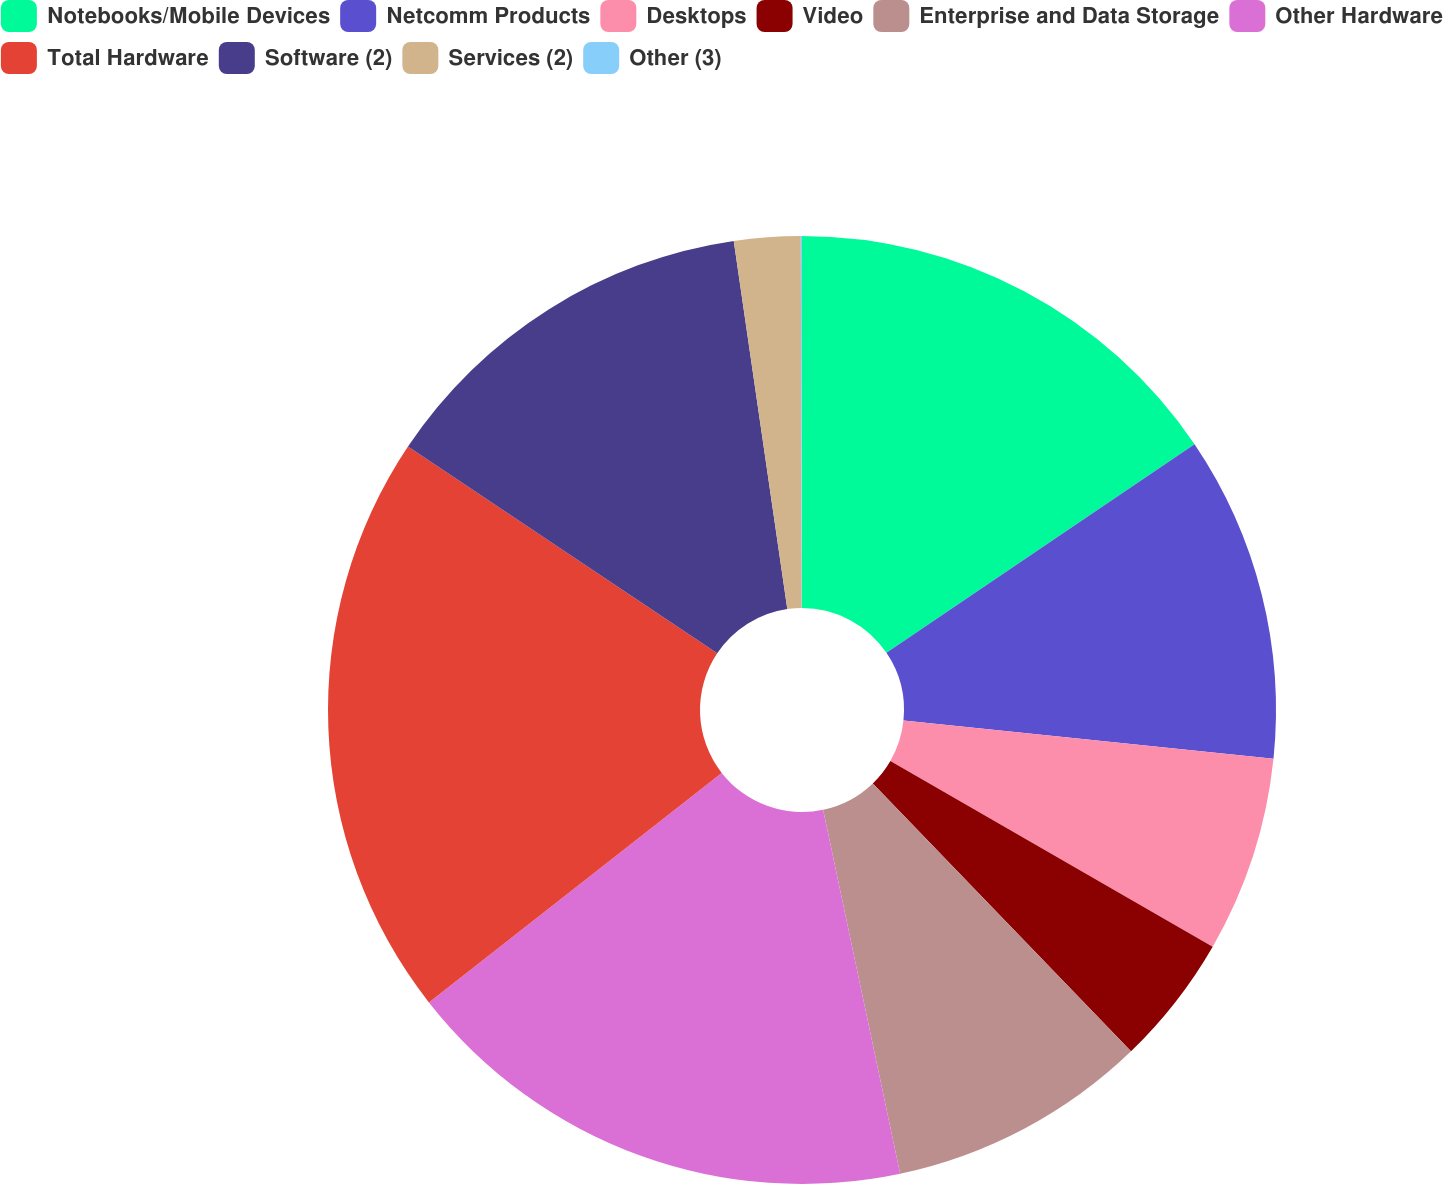Convert chart. <chart><loc_0><loc_0><loc_500><loc_500><pie_chart><fcel>Notebooks/Mobile Devices<fcel>Netcomm Products<fcel>Desktops<fcel>Video<fcel>Enterprise and Data Storage<fcel>Other Hardware<fcel>Total Hardware<fcel>Software (2)<fcel>Services (2)<fcel>Other (3)<nl><fcel>15.53%<fcel>11.11%<fcel>6.68%<fcel>4.47%<fcel>8.89%<fcel>17.74%<fcel>19.96%<fcel>13.32%<fcel>2.26%<fcel>0.04%<nl></chart> 